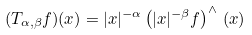<formula> <loc_0><loc_0><loc_500><loc_500>( T _ { \alpha , \beta } f ) ( x ) = | x | ^ { - \alpha } \left ( | x | ^ { - \beta } f \right ) ^ { \wedge } \, ( x )</formula> 